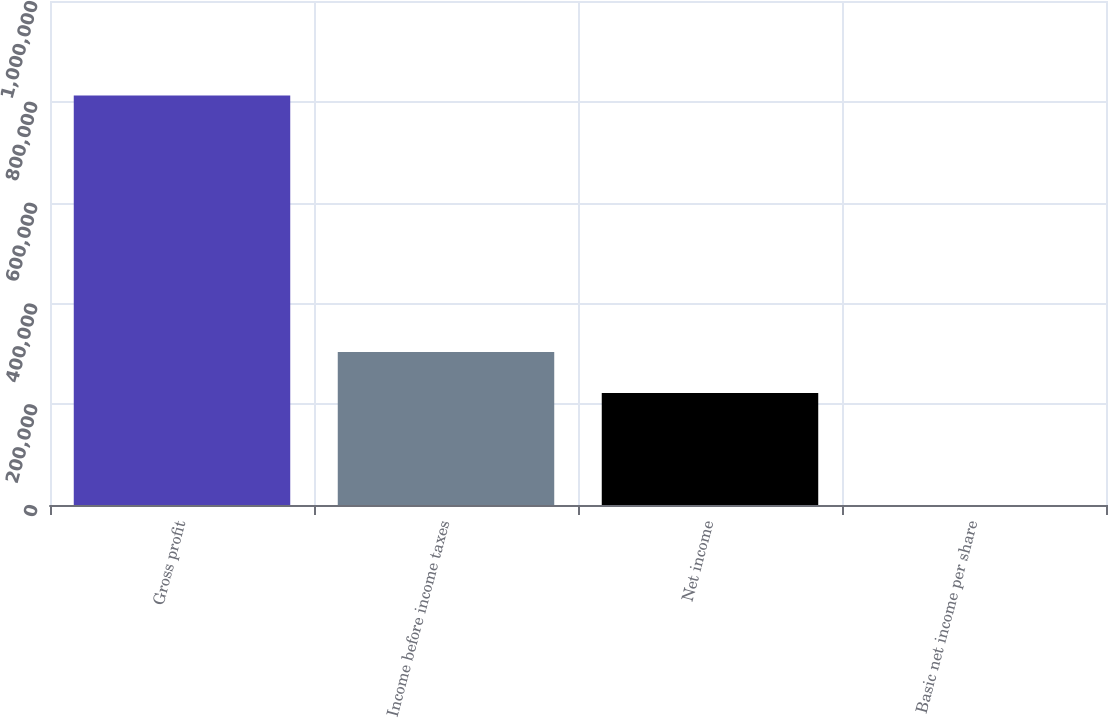Convert chart. <chart><loc_0><loc_0><loc_500><loc_500><bar_chart><fcel>Gross profit<fcel>Income before income taxes<fcel>Net income<fcel>Basic net income per share<nl><fcel>812615<fcel>303469<fcel>222208<fcel>0.39<nl></chart> 